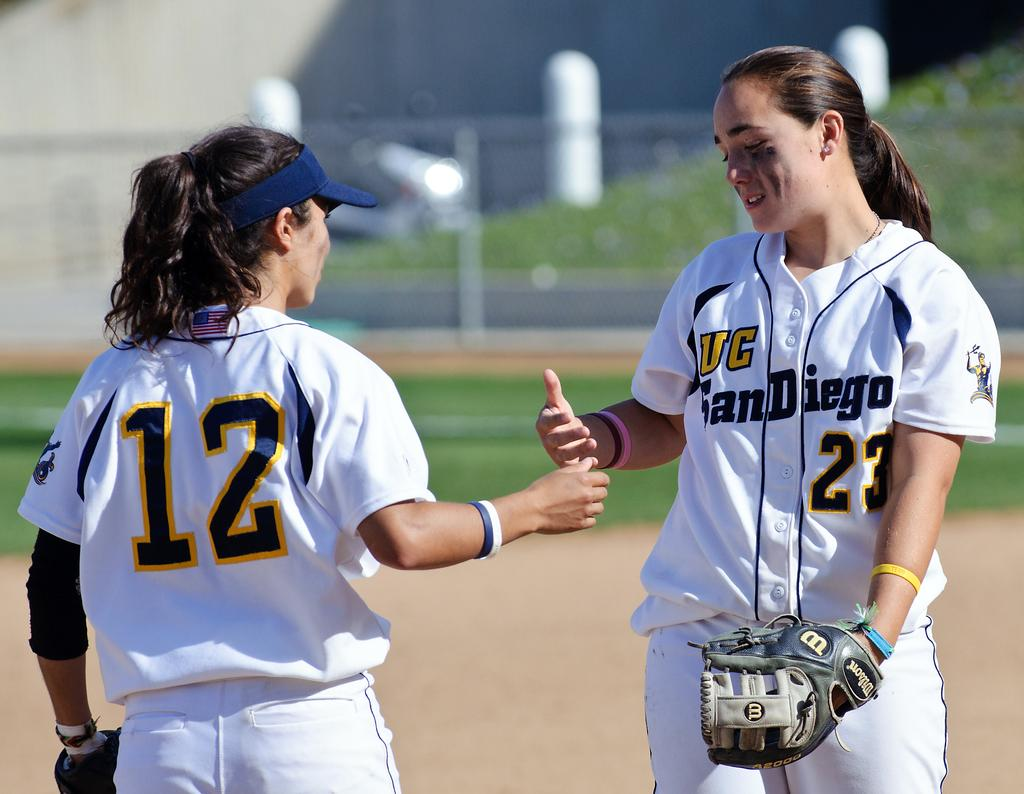Provide a one-sentence caption for the provided image. Two female softball players from the University of San Diego about to shake hands. 